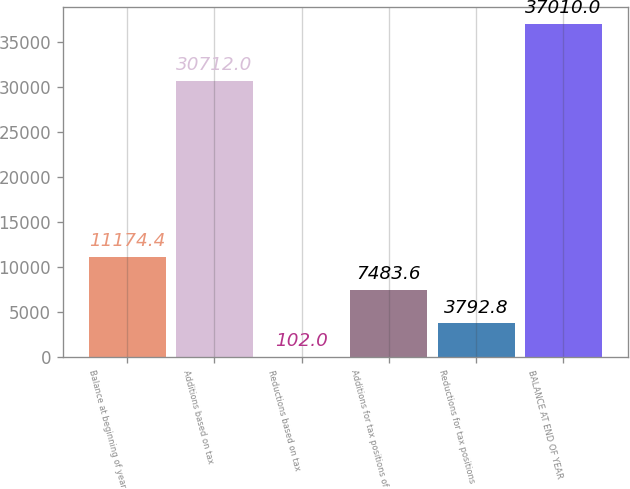Convert chart to OTSL. <chart><loc_0><loc_0><loc_500><loc_500><bar_chart><fcel>Balance at beginning of year<fcel>Additions based on tax<fcel>Reductions based on tax<fcel>Additions for tax positions of<fcel>Reductions for tax positions<fcel>BALANCE AT END OF YEAR<nl><fcel>11174.4<fcel>30712<fcel>102<fcel>7483.6<fcel>3792.8<fcel>37010<nl></chart> 